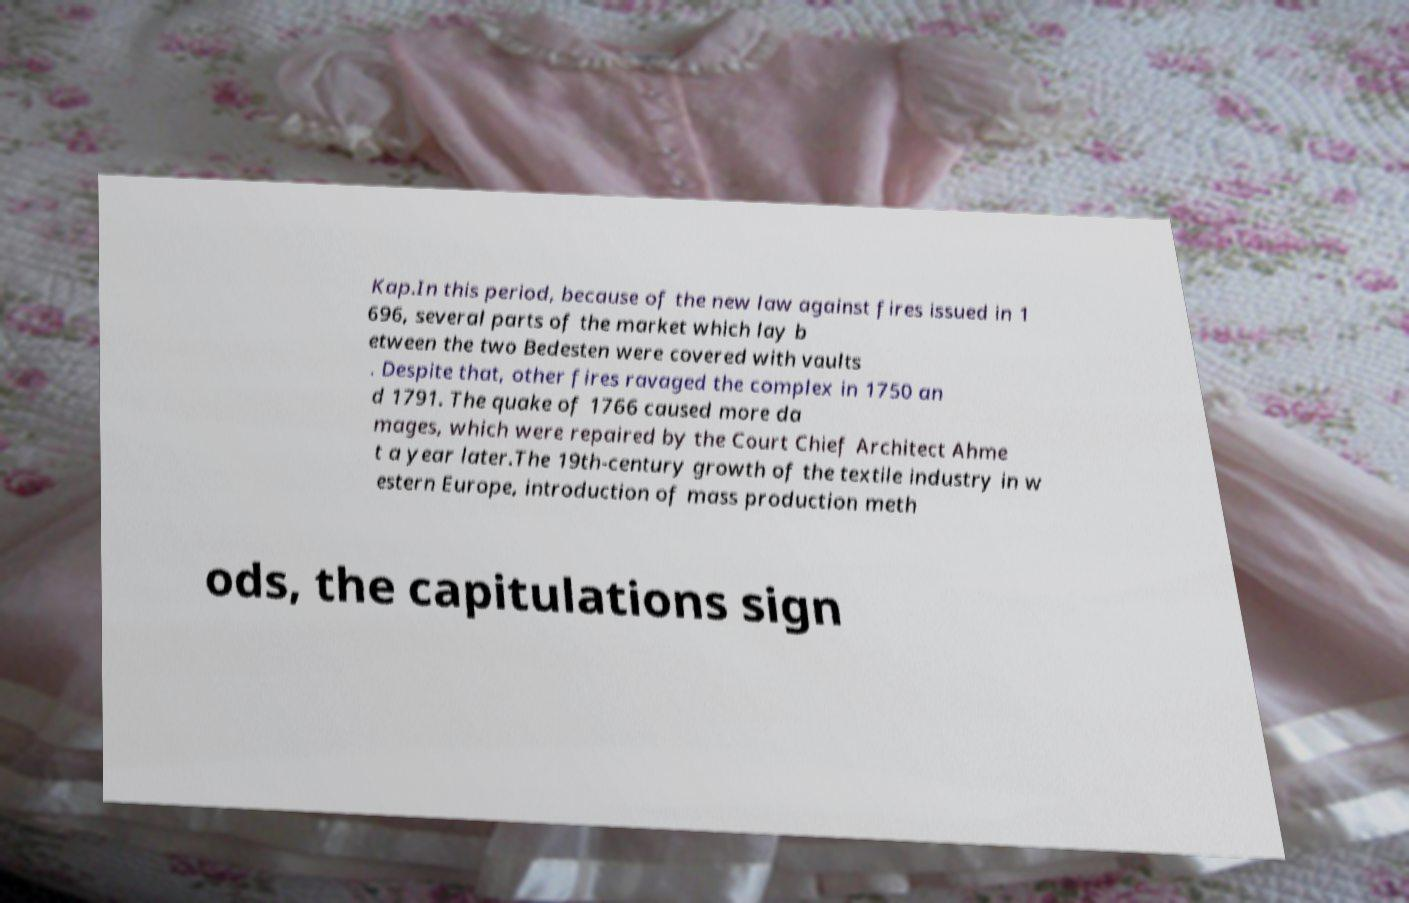Can you read and provide the text displayed in the image?This photo seems to have some interesting text. Can you extract and type it out for me? Kap.In this period, because of the new law against fires issued in 1 696, several parts of the market which lay b etween the two Bedesten were covered with vaults . Despite that, other fires ravaged the complex in 1750 an d 1791. The quake of 1766 caused more da mages, which were repaired by the Court Chief Architect Ahme t a year later.The 19th-century growth of the textile industry in w estern Europe, introduction of mass production meth ods, the capitulations sign 